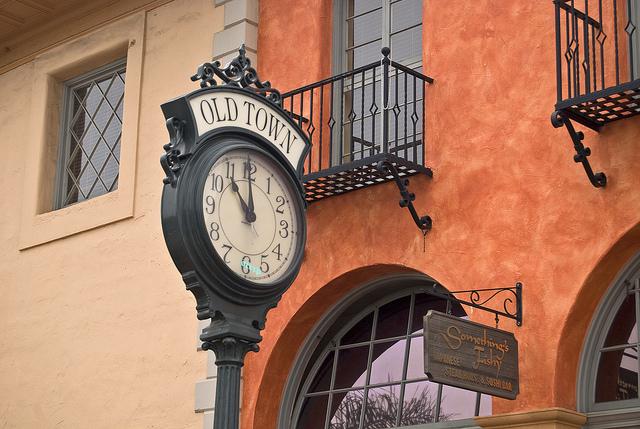What is the name of the business on the sign?
Short answer required. Something's fishy. Could the time be 11:00 PM?
Short answer required. Yes. What fast food place is behind the clock?
Be succinct. Something's fishy. Can you see the number 5?
Be succinct. Yes. What color is the building?
Answer briefly. Orange. 